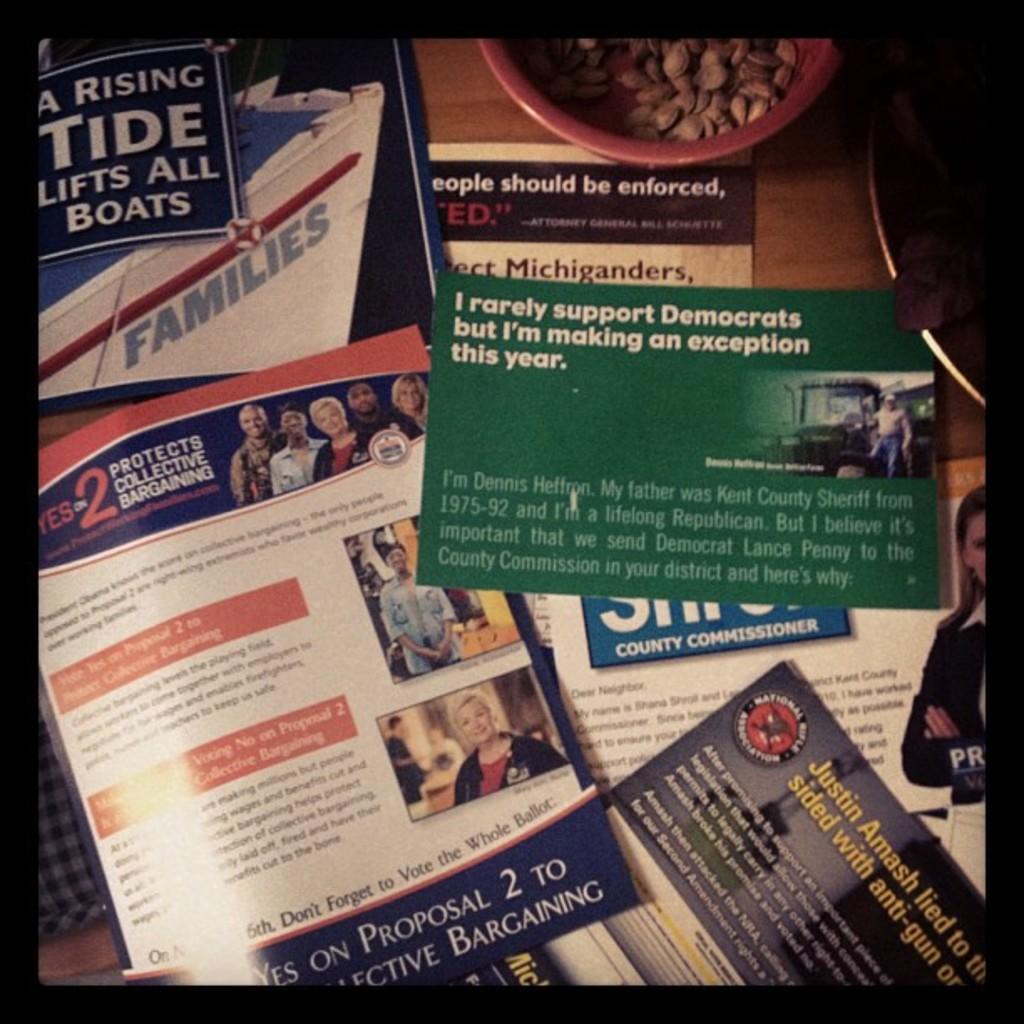In one or two sentences, can you explain what this image depicts? In the image there are few papers with some information and beside the papers there are some nuts. 